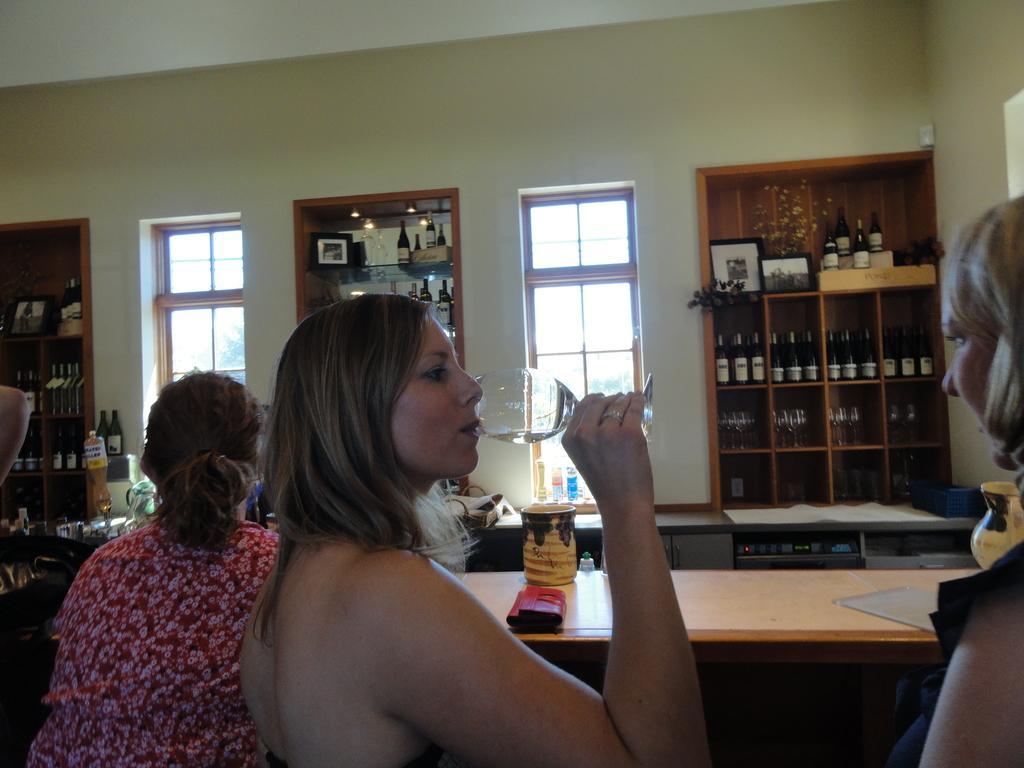How would you summarize this image in a sentence or two? In this image there are three women who are sitting and in the middle there is one woman and she is holding a glass and drinking, and on the top there is ceiling and in the middle there is wall and two windows are there. And three cupboards are there and in that cupboard there are some bottles and glasses are there, and in the bottom of the image there are two tables and on the tables there are some papers. 